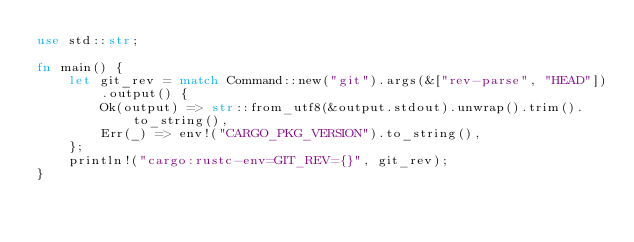<code> <loc_0><loc_0><loc_500><loc_500><_Rust_>use std::str;

fn main() {
    let git_rev = match Command::new("git").args(&["rev-parse", "HEAD"]).output() {
        Ok(output) => str::from_utf8(&output.stdout).unwrap().trim().to_string(),
        Err(_) => env!("CARGO_PKG_VERSION").to_string(),
    };
    println!("cargo:rustc-env=GIT_REV={}", git_rev);
}
</code> 